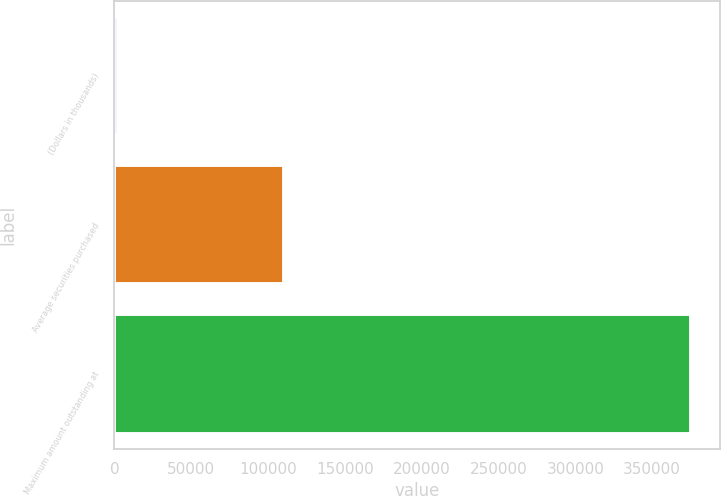<chart> <loc_0><loc_0><loc_500><loc_500><bar_chart><fcel>(Dollars in thousands)<fcel>Average securities purchased<fcel>Maximum amount outstanding at<nl><fcel>2011<fcel>110291<fcel>375236<nl></chart> 